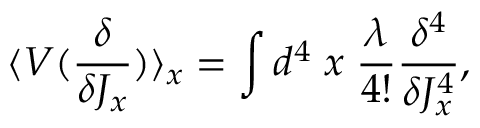Convert formula to latex. <formula><loc_0><loc_0><loc_500><loc_500>\langle V ( \frac { \delta } { \delta J _ { x } } ) \rangle _ { x } = \int d ^ { 4 } \, x \, \frac { \lambda } { 4 ! } \frac { \delta ^ { 4 } } { \delta J _ { x } ^ { 4 } } ,</formula> 